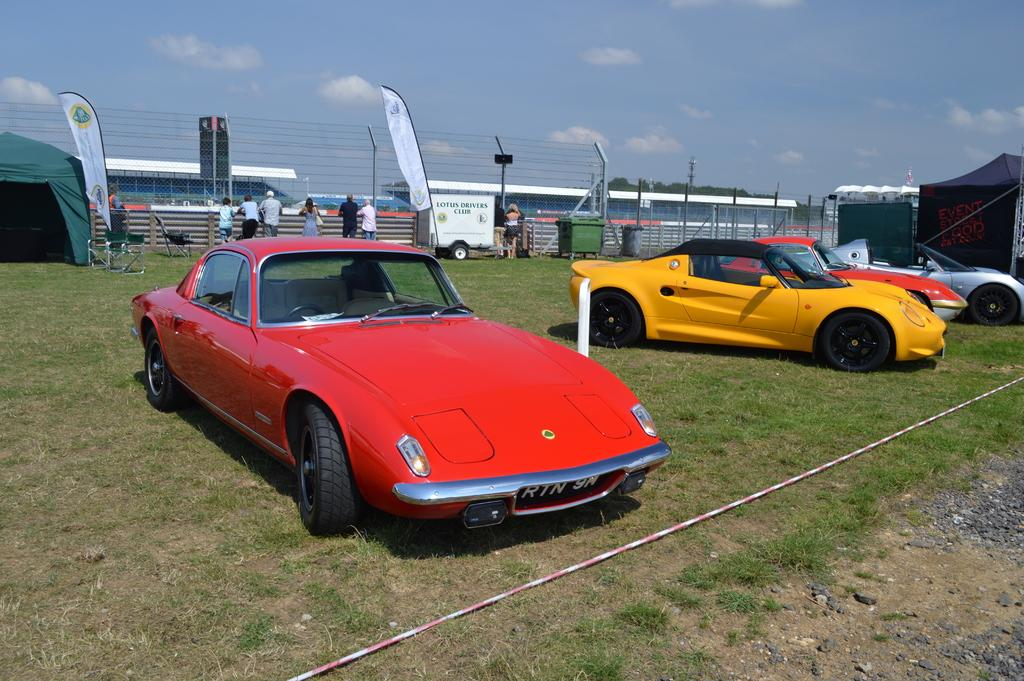What type of vehicles can be seen in the image? There are cars in the image. What are the people in the image doing? The people in the image are standing on the ground. What is the purpose of the fence in the image? The purpose of the fence in the image is not specified, but it could be for enclosing an area or providing a barrier. What are the banners in the image used for? The banners in the image could be used for advertising, promoting an event, or providing information. What type of temporary shelters are present in the image? There are tents in the image. What type of vegetation is present in the image? There are trees in the image. What is visible in the background of the image? The sky is visible in the background of the image. What can be seen in the sky in the image? Clouds are present in the sky. What flavor of ticket can be seen in the image? There are no tickets present in the image, and therefore no flavor can be associated with them. Are there any mountains visible in the image? There are no mountains present in the image; it features cars, people, a fence, banners, tents, trees, and a sky with clouds. 